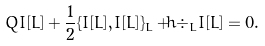Convert formula to latex. <formula><loc_0><loc_0><loc_500><loc_500>Q I [ L ] + \frac { 1 } { 2 } \{ I [ L ] , I [ L ] \} _ { L } + \hbar { \div } _ { L } I [ L ] = 0 .</formula> 